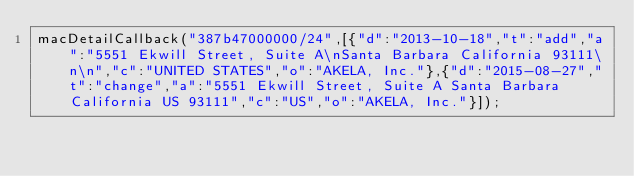Convert code to text. <code><loc_0><loc_0><loc_500><loc_500><_JavaScript_>macDetailCallback("387b47000000/24",[{"d":"2013-10-18","t":"add","a":"5551 Ekwill Street, Suite A\nSanta Barbara California 93111\n\n","c":"UNITED STATES","o":"AKELA, Inc."},{"d":"2015-08-27","t":"change","a":"5551 Ekwill Street, Suite A Santa Barbara California US 93111","c":"US","o":"AKELA, Inc."}]);
</code> 